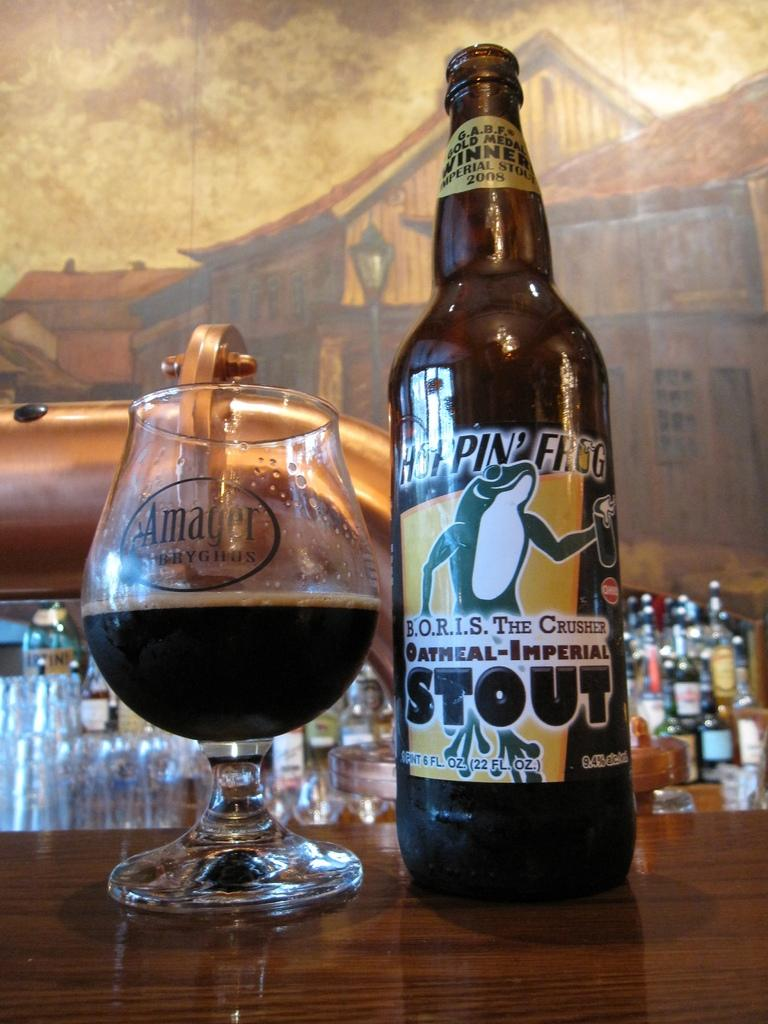Provide a one-sentence caption for the provided image. Bottle of Oatmeal-Imperial Stout on the bar next to a wine glass half full. 